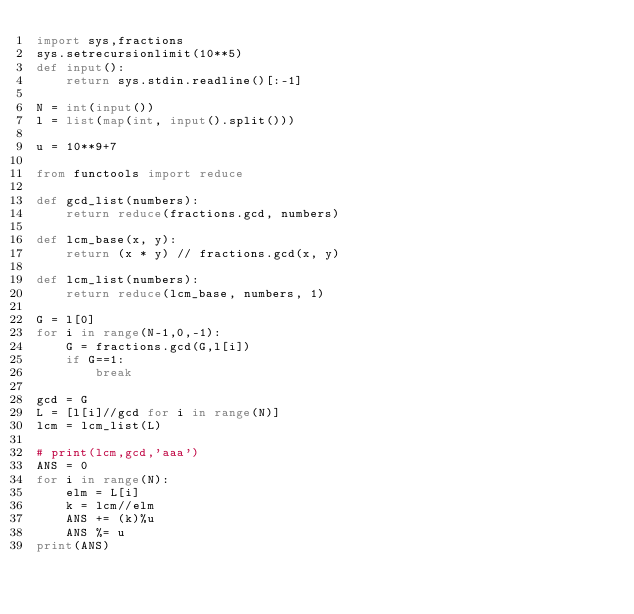Convert code to text. <code><loc_0><loc_0><loc_500><loc_500><_Python_>import sys,fractions
sys.setrecursionlimit(10**5)
def input():
    return sys.stdin.readline()[:-1]

N = int(input())
l = list(map(int, input().split()))

u = 10**9+7

from functools import reduce

def gcd_list(numbers):
    return reduce(fractions.gcd, numbers)

def lcm_base(x, y):
    return (x * y) // fractions.gcd(x, y)

def lcm_list(numbers):
    return reduce(lcm_base, numbers, 1)

G = l[0]
for i in range(N-1,0,-1):
    G = fractions.gcd(G,l[i])
    if G==1:
        break

gcd = G
L = [l[i]//gcd for i in range(N)]
lcm = lcm_list(L)

# print(lcm,gcd,'aaa')
ANS = 0
for i in range(N):
    elm = L[i]
    k = lcm//elm
    ANS += (k)%u
    ANS %= u
print(ANS)</code> 